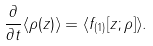Convert formula to latex. <formula><loc_0><loc_0><loc_500><loc_500>\frac { \partial } { \partial t } \langle \rho ( z ) \rangle = \langle f _ { ( 1 ) } [ z ; \rho ] \rangle .</formula> 